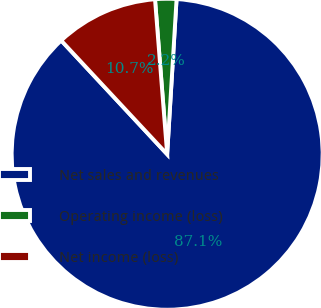<chart> <loc_0><loc_0><loc_500><loc_500><pie_chart><fcel>Net sales and revenues<fcel>Operating income (loss)<fcel>Net income (loss)<nl><fcel>87.1%<fcel>2.21%<fcel>10.69%<nl></chart> 